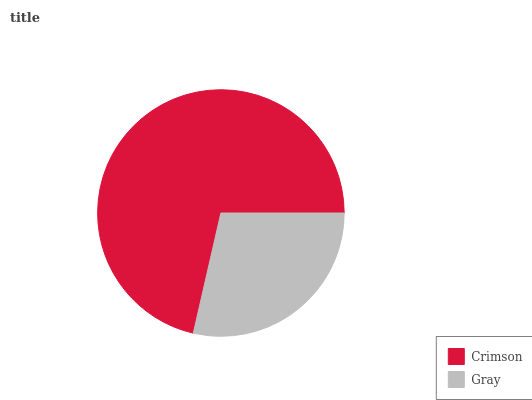Is Gray the minimum?
Answer yes or no. Yes. Is Crimson the maximum?
Answer yes or no. Yes. Is Gray the maximum?
Answer yes or no. No. Is Crimson greater than Gray?
Answer yes or no. Yes. Is Gray less than Crimson?
Answer yes or no. Yes. Is Gray greater than Crimson?
Answer yes or no. No. Is Crimson less than Gray?
Answer yes or no. No. Is Crimson the high median?
Answer yes or no. Yes. Is Gray the low median?
Answer yes or no. Yes. Is Gray the high median?
Answer yes or no. No. Is Crimson the low median?
Answer yes or no. No. 